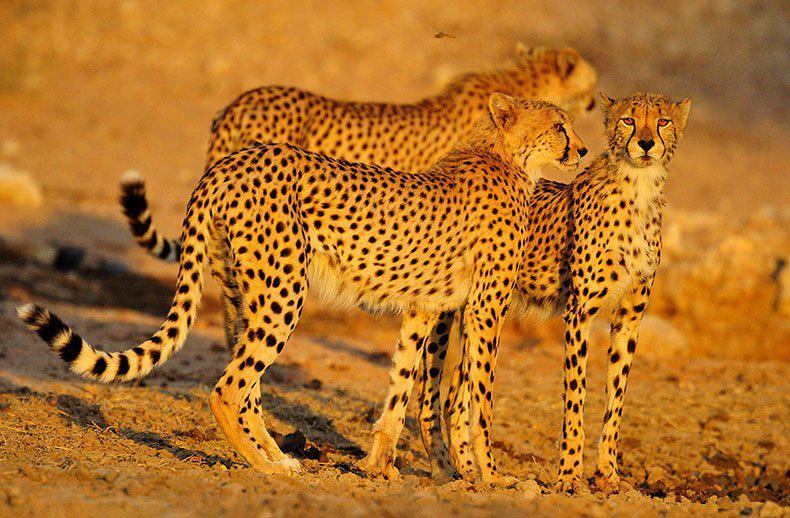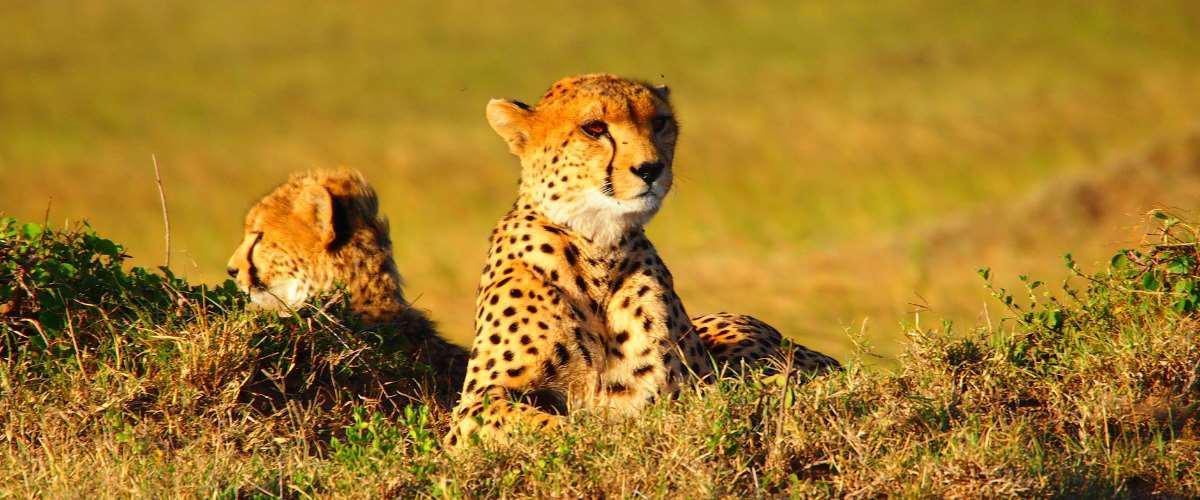The first image is the image on the left, the second image is the image on the right. For the images shown, is this caption "The right image contains no more than two cheetahs." true? Answer yes or no. Yes. The first image is the image on the left, the second image is the image on the right. Assess this claim about the two images: "Two of the cats in the image on the right are lying on the ground.". Correct or not? Answer yes or no. Yes. 